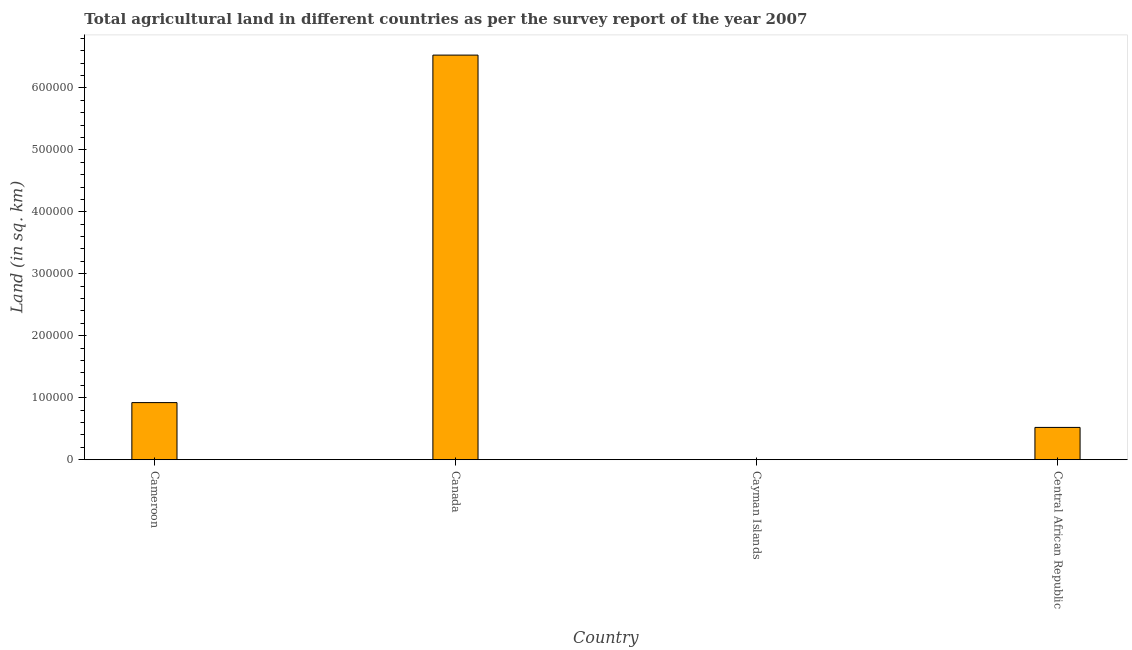Does the graph contain grids?
Ensure brevity in your answer.  No. What is the title of the graph?
Your response must be concise. Total agricultural land in different countries as per the survey report of the year 2007. What is the label or title of the Y-axis?
Your answer should be very brief. Land (in sq. km). What is the agricultural land in Canada?
Provide a succinct answer. 6.53e+05. Across all countries, what is the maximum agricultural land?
Your answer should be very brief. 6.53e+05. Across all countries, what is the minimum agricultural land?
Ensure brevity in your answer.  27. In which country was the agricultural land minimum?
Ensure brevity in your answer.  Cayman Islands. What is the sum of the agricultural land?
Ensure brevity in your answer.  7.97e+05. What is the difference between the agricultural land in Cameroon and Canada?
Offer a terse response. -5.61e+05. What is the average agricultural land per country?
Offer a terse response. 1.99e+05. What is the median agricultural land?
Make the answer very short. 7.21e+04. In how many countries, is the agricultural land greater than 280000 sq. km?
Provide a short and direct response. 1. Is the agricultural land in Cameroon less than that in Canada?
Offer a terse response. Yes. Is the difference between the agricultural land in Cayman Islands and Central African Republic greater than the difference between any two countries?
Offer a terse response. No. What is the difference between the highest and the second highest agricultural land?
Your answer should be compact. 5.61e+05. What is the difference between the highest and the lowest agricultural land?
Make the answer very short. 6.53e+05. In how many countries, is the agricultural land greater than the average agricultural land taken over all countries?
Provide a succinct answer. 1. What is the Land (in sq. km) in Cameroon?
Offer a terse response. 9.21e+04. What is the Land (in sq. km) of Canada?
Offer a very short reply. 6.53e+05. What is the Land (in sq. km) in Cayman Islands?
Offer a terse response. 27. What is the Land (in sq. km) in Central African Republic?
Give a very brief answer. 5.21e+04. What is the difference between the Land (in sq. km) in Cameroon and Canada?
Give a very brief answer. -5.61e+05. What is the difference between the Land (in sq. km) in Cameroon and Cayman Islands?
Offer a terse response. 9.21e+04. What is the difference between the Land (in sq. km) in Cameroon and Central African Republic?
Keep it short and to the point. 4.00e+04. What is the difference between the Land (in sq. km) in Canada and Cayman Islands?
Your answer should be very brief. 6.53e+05. What is the difference between the Land (in sq. km) in Canada and Central African Republic?
Provide a succinct answer. 6.01e+05. What is the difference between the Land (in sq. km) in Cayman Islands and Central African Republic?
Make the answer very short. -5.21e+04. What is the ratio of the Land (in sq. km) in Cameroon to that in Canada?
Offer a terse response. 0.14. What is the ratio of the Land (in sq. km) in Cameroon to that in Cayman Islands?
Your answer should be compact. 3412.22. What is the ratio of the Land (in sq. km) in Cameroon to that in Central African Republic?
Offer a very short reply. 1.77. What is the ratio of the Land (in sq. km) in Canada to that in Cayman Islands?
Your answer should be compact. 2.42e+04. What is the ratio of the Land (in sq. km) in Canada to that in Central African Republic?
Make the answer very short. 12.53. What is the ratio of the Land (in sq. km) in Cayman Islands to that in Central African Republic?
Keep it short and to the point. 0. 